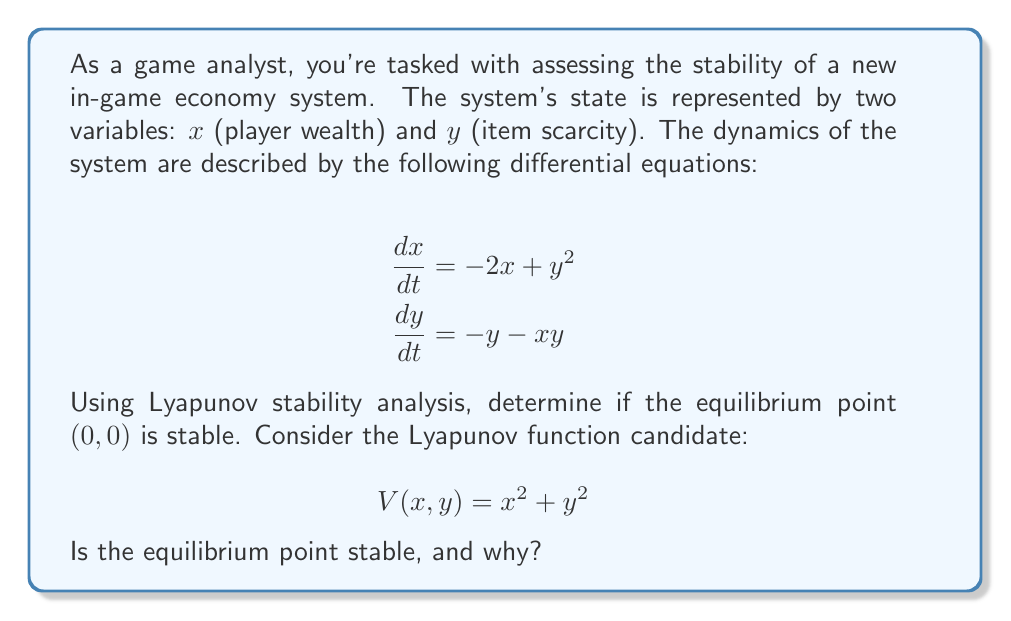What is the answer to this math problem? To determine the stability of the equilibrium point $(0,0)$ using Lyapunov stability analysis, we need to follow these steps:

1. Verify that $V(x,y)$ is positive definite:
   $V(x,y) = x^2 + y^2 > 0$ for all $(x,y) \neq (0,0)$, and $V(0,0) = 0$.

2. Calculate $\dot{V}(x,y)$:
   $$\dot{V}(x,y) = \frac{\partial V}{\partial x}\frac{dx}{dt} + \frac{\partial V}{\partial y}\frac{dy}{dt}$$
   $$\dot{V}(x,y) = 2x(-2x+y^2) + 2y(-y-xy)$$
   $$\dot{V}(x,y) = -4x^2 + 2xy^2 - 2y^2 - 2xy^2$$
   $$\dot{V}(x,y) = -4x^2 - 2y^2$$

3. Analyze $\dot{V}(x,y)$:
   $\dot{V}(x,y) = -4x^2 - 2y^2 < 0$ for all $(x,y) \neq (0,0)$, and $\dot{V}(0,0) = 0$.

4. Conclusion:
   Since $V(x,y)$ is positive definite and $\dot{V}(x,y)$ is negative definite, according to Lyapunov's stability theorem, the equilibrium point $(0,0)$ is asymptotically stable.

This means that the in-game economy system will naturally tend towards the equilibrium state where both player wealth and item scarcity approach zero, regardless of the initial conditions. The system is self-correcting and will maintain balance over time.
Answer: The equilibrium point $(0,0)$ is asymptotically stable. 